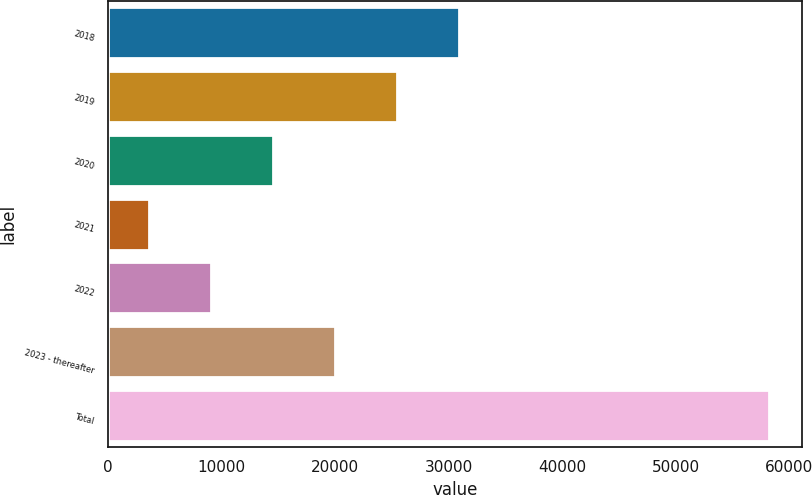Convert chart. <chart><loc_0><loc_0><loc_500><loc_500><bar_chart><fcel>2018<fcel>2019<fcel>2020<fcel>2021<fcel>2022<fcel>2023 - thereafter<fcel>Total<nl><fcel>30917.5<fcel>25457.4<fcel>14537.2<fcel>3617<fcel>9077.1<fcel>19997.3<fcel>58218<nl></chart> 